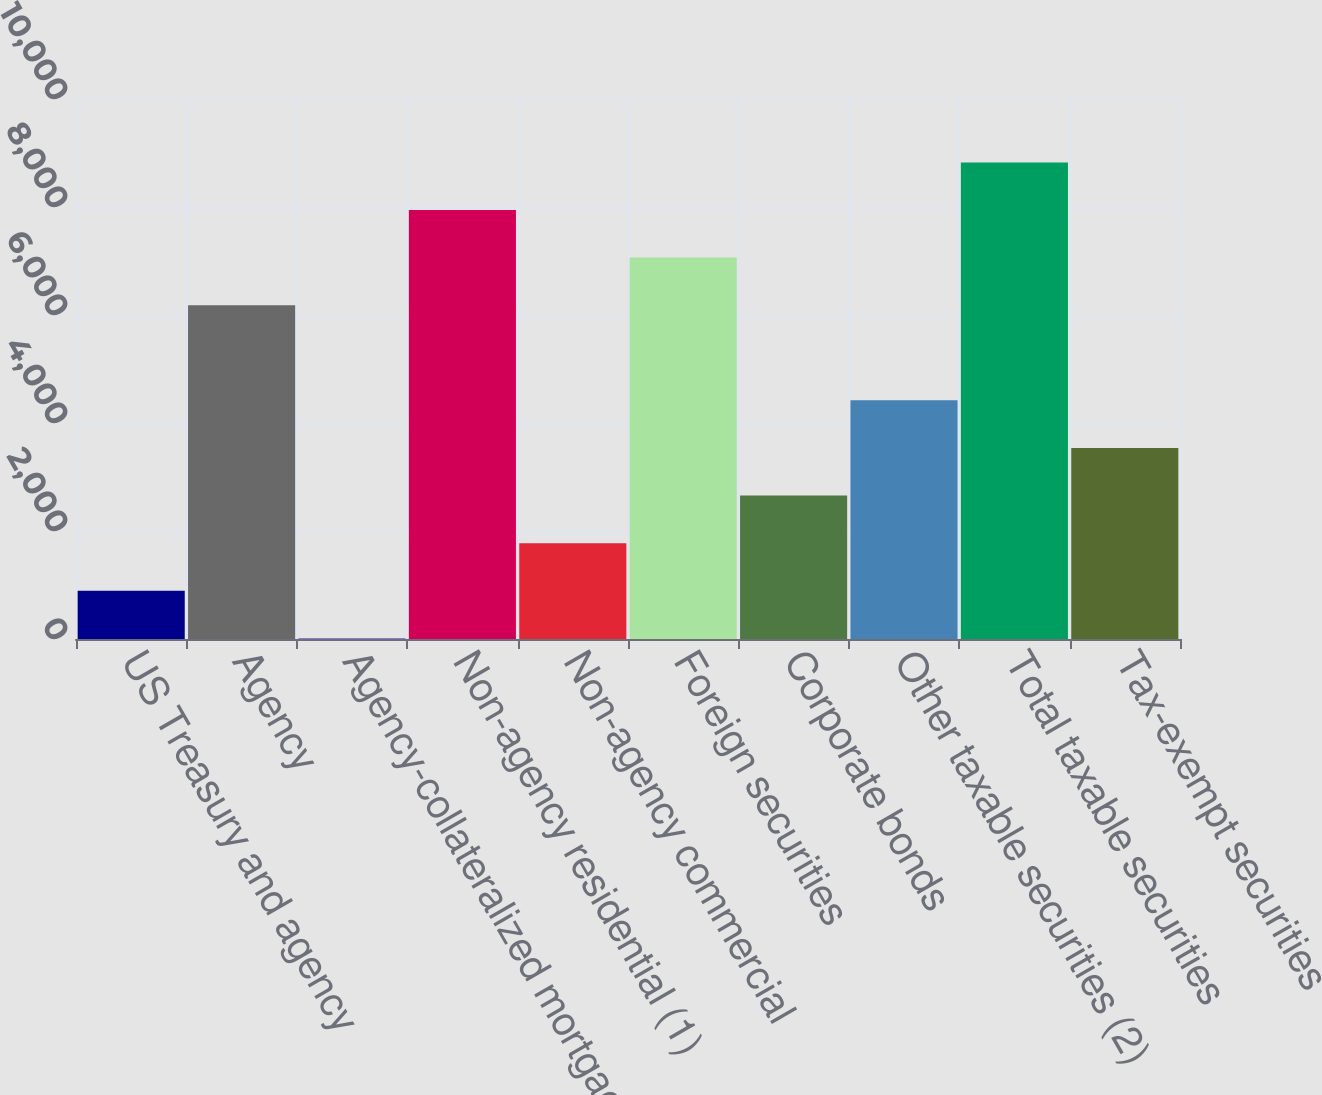Convert chart. <chart><loc_0><loc_0><loc_500><loc_500><bar_chart><fcel>US Treasury and agency<fcel>Agency<fcel>Agency-collateralized mortgage<fcel>Non-agency residential (1)<fcel>Non-agency commercial<fcel>Foreign securities<fcel>Corporate bonds<fcel>Other taxable securities (2)<fcel>Total taxable securities<fcel>Tax-exempt securities<nl><fcel>894.2<fcel>6181.4<fcel>13<fcel>7943.8<fcel>1775.4<fcel>7062.6<fcel>2656.6<fcel>4419<fcel>8825<fcel>3537.8<nl></chart> 